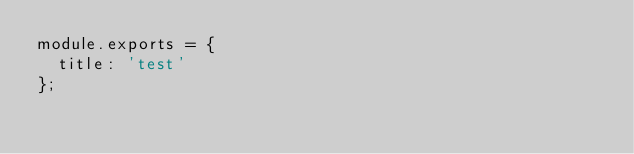Convert code to text. <code><loc_0><loc_0><loc_500><loc_500><_JavaScript_>module.exports = {
  title: 'test'
};
</code> 